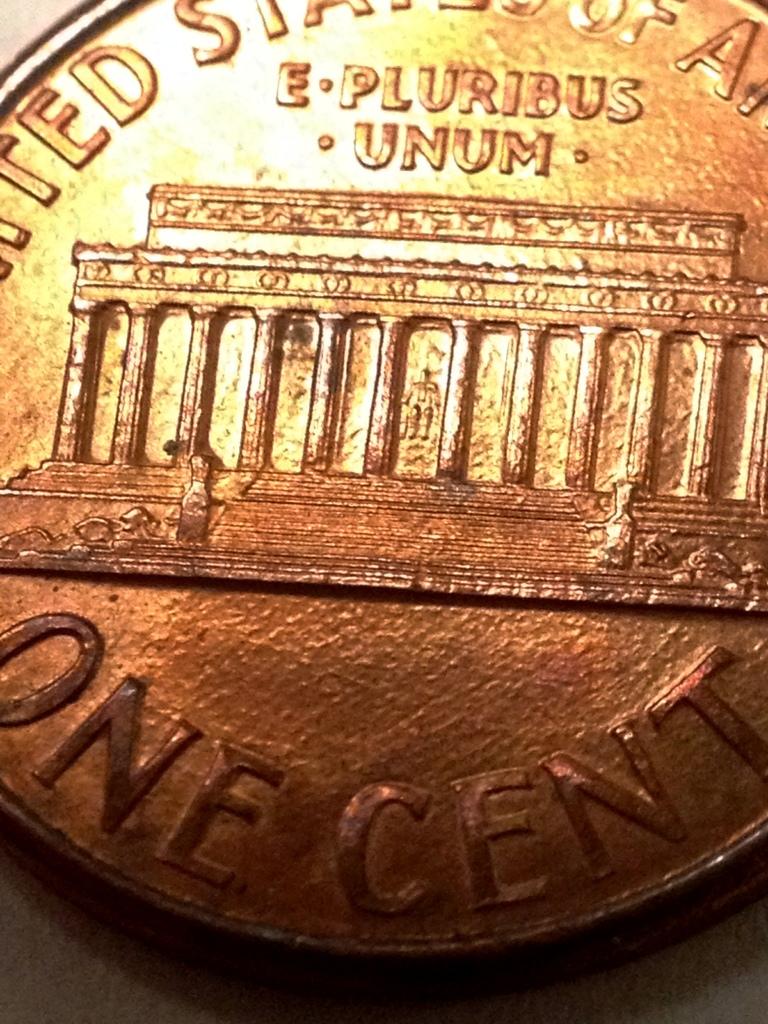What is this coin?
Offer a terse response. One cent. What cent is the coin?
Give a very brief answer. One. 